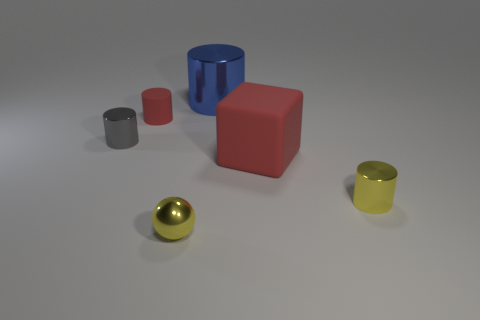Subtract all tiny gray shiny cylinders. How many cylinders are left? 3 Add 4 big brown metallic things. How many objects exist? 10 Subtract all blue cylinders. How many cylinders are left? 3 Subtract 1 cylinders. How many cylinders are left? 3 Subtract all spheres. How many objects are left? 5 Subtract all gray cylinders. Subtract all blue blocks. How many cylinders are left? 3 Subtract 1 red cylinders. How many objects are left? 5 Subtract all small cyan matte blocks. Subtract all small metallic cylinders. How many objects are left? 4 Add 5 blue cylinders. How many blue cylinders are left? 6 Add 5 gray spheres. How many gray spheres exist? 5 